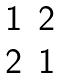<formula> <loc_0><loc_0><loc_500><loc_500>\begin{matrix} 1 & 2 \\ 2 & 1 \\ \end{matrix}</formula> 